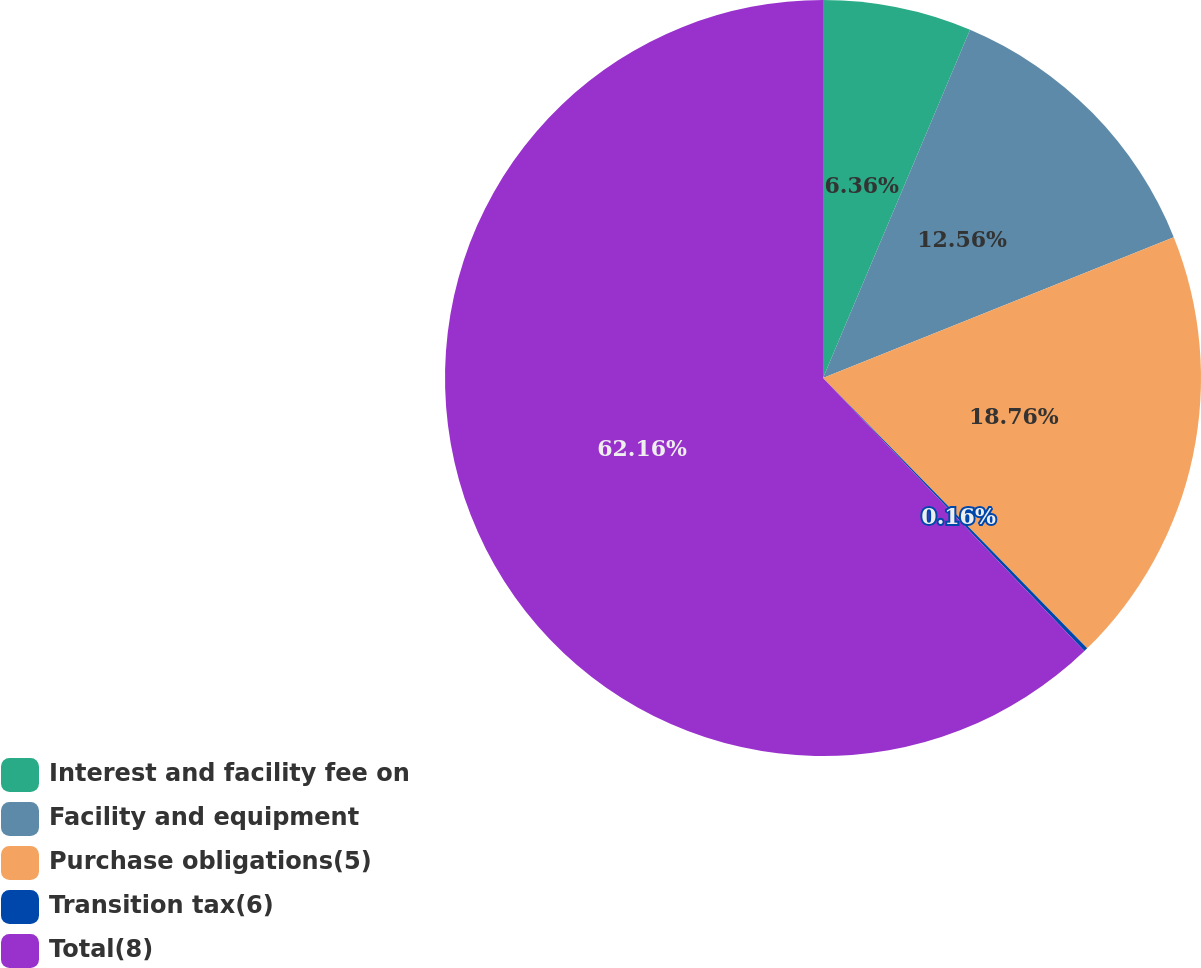<chart> <loc_0><loc_0><loc_500><loc_500><pie_chart><fcel>Interest and facility fee on<fcel>Facility and equipment<fcel>Purchase obligations(5)<fcel>Transition tax(6)<fcel>Total(8)<nl><fcel>6.36%<fcel>12.56%<fcel>18.76%<fcel>0.16%<fcel>62.15%<nl></chart> 